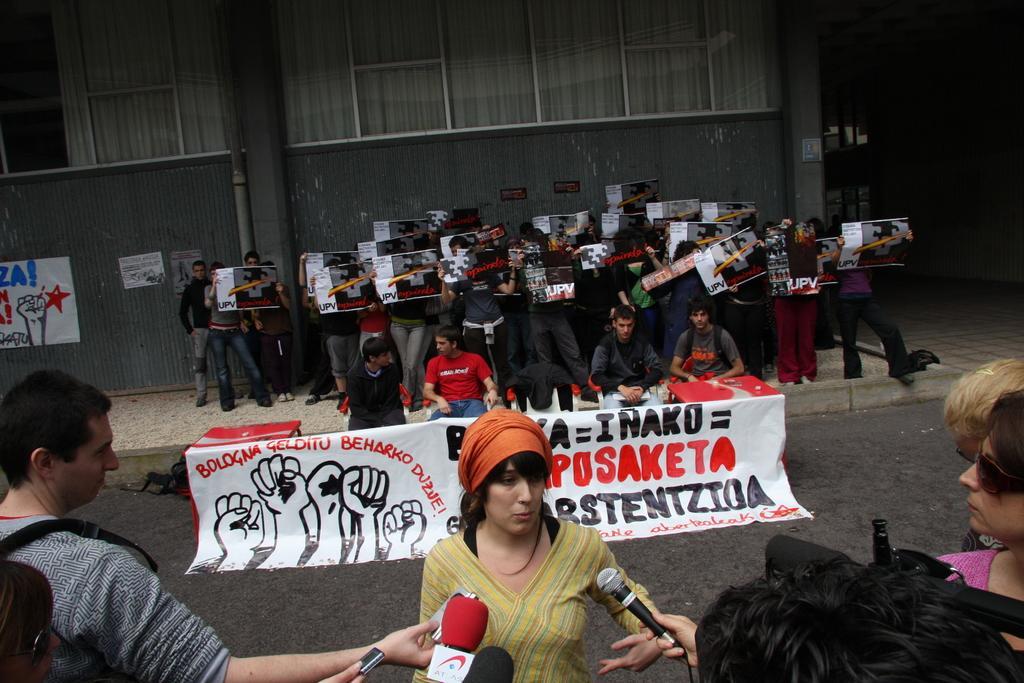Could you give a brief overview of what you see in this image? In this picture, we can see a few people holding some objects like posters, microphones, and a few are sitting, we can see chairs, posters with text, and we can see the wall, poster with some text on it. 